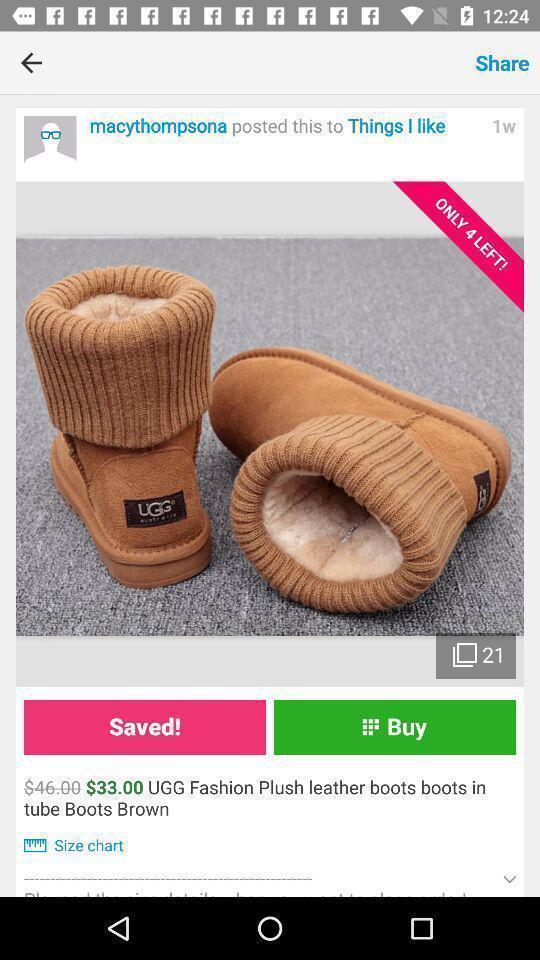Explain the elements present in this screenshot. Screen displaying product details with price. 